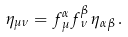<formula> <loc_0><loc_0><loc_500><loc_500>\eta _ { \mu \nu } = f ^ { \alpha } _ { \, \mu } f ^ { \beta } _ { \, \nu } \, \eta _ { \alpha \beta } \, .</formula> 